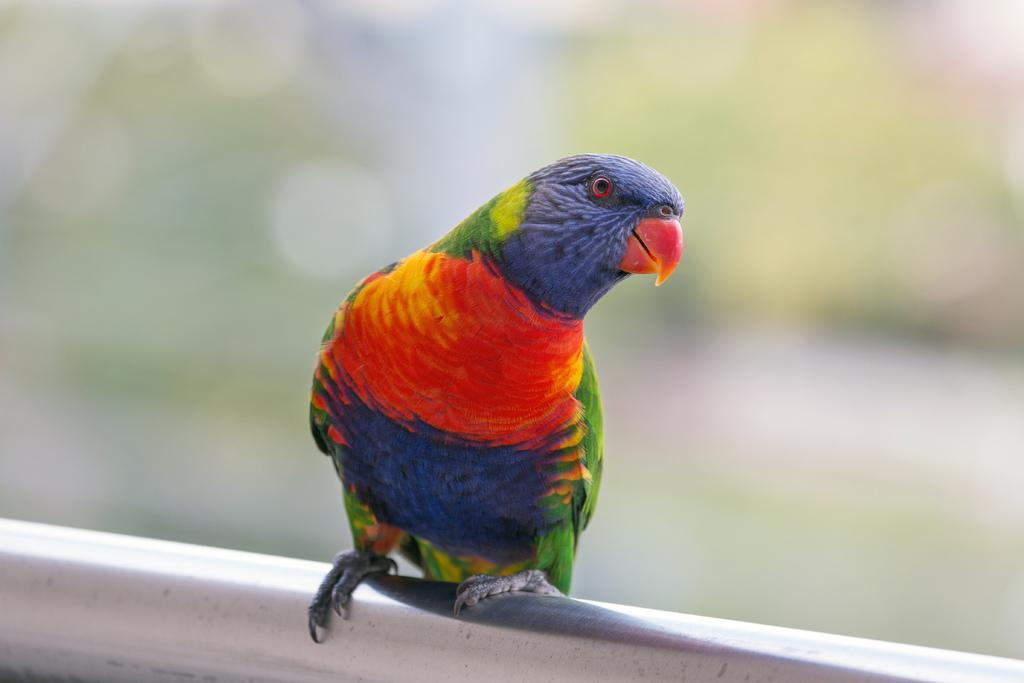What type of animal is in the image? There is a bird in the image. Where is the bird located in relation to the image? The bird is in the front of the image. What can be observed about the background of the image? The background of the image is blurred. What type of ball is visible in the image? There is no ball present in the image. Can you describe the snake in the image? There is no snake present in the image. 